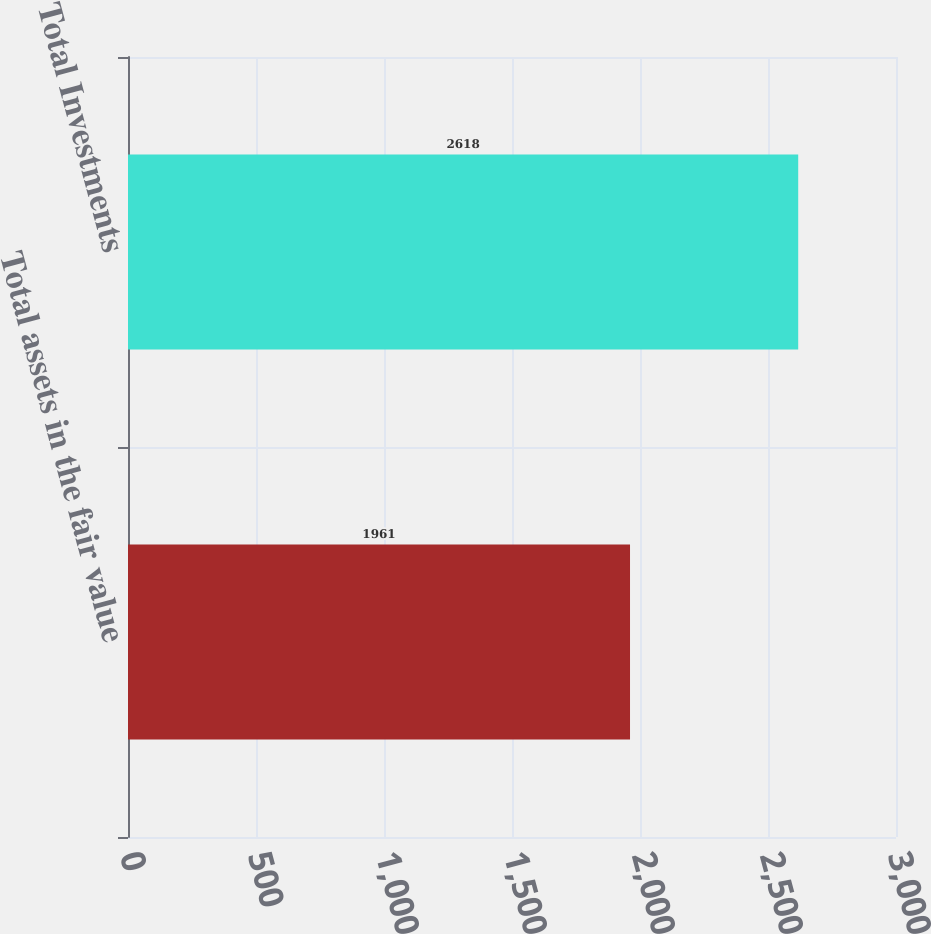Convert chart to OTSL. <chart><loc_0><loc_0><loc_500><loc_500><bar_chart><fcel>Total assets in the fair value<fcel>Total Investments<nl><fcel>1961<fcel>2618<nl></chart> 